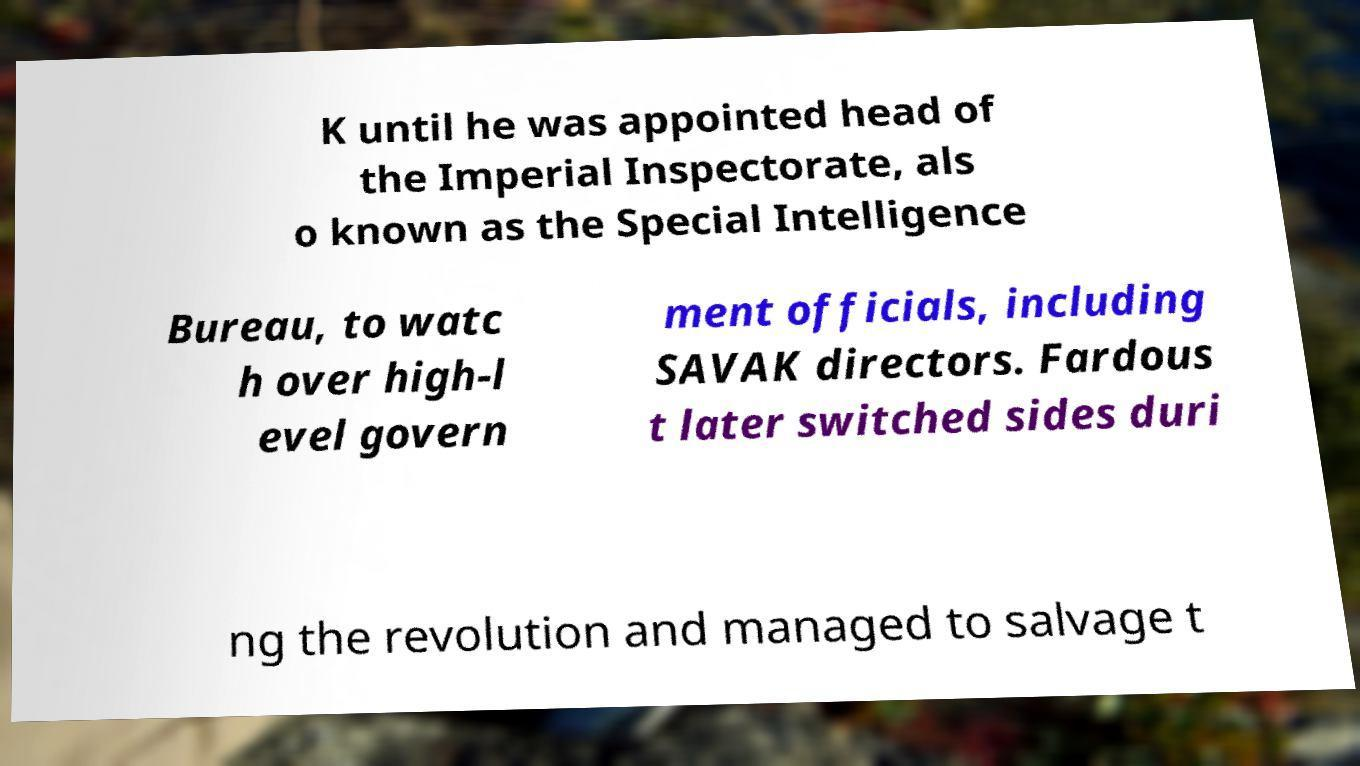Could you extract and type out the text from this image? K until he was appointed head of the Imperial Inspectorate, als o known as the Special Intelligence Bureau, to watc h over high-l evel govern ment officials, including SAVAK directors. Fardous t later switched sides duri ng the revolution and managed to salvage t 